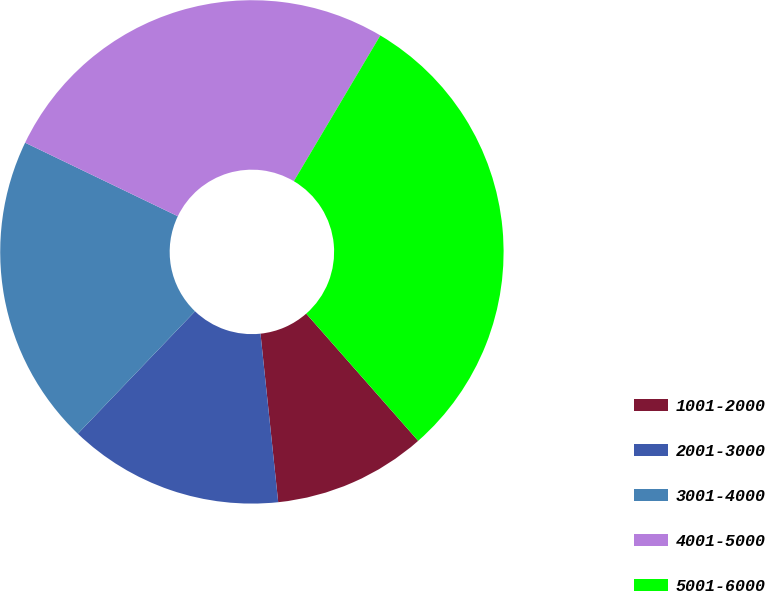Convert chart. <chart><loc_0><loc_0><loc_500><loc_500><pie_chart><fcel>1001-2000<fcel>2001-3000<fcel>3001-4000<fcel>4001-5000<fcel>5001-6000<nl><fcel>9.82%<fcel>13.82%<fcel>19.99%<fcel>26.38%<fcel>29.99%<nl></chart> 